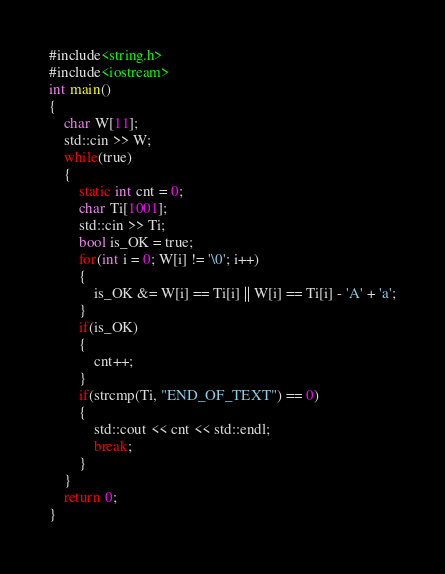<code> <loc_0><loc_0><loc_500><loc_500><_C++_>#include<string.h>
#include<iostream>
int main()
{
	char W[11];
	std::cin >> W;
	while(true)
	{
		static int cnt = 0;
		char Ti[1001];
		std::cin >> Ti;
		bool is_OK = true;
		for(int i = 0; W[i] != '\0'; i++)
		{
			is_OK &= W[i] == Ti[i] || W[i] == Ti[i] - 'A' + 'a';
		}
		if(is_OK)
		{
			cnt++;
		}
		if(strcmp(Ti, "END_OF_TEXT") == 0)
		{
			std::cout << cnt << std::endl;
			break;
		}
	}
	return 0;
}
</code> 